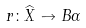<formula> <loc_0><loc_0><loc_500><loc_500>r \colon \widehat { X } \to B \Gamma</formula> 